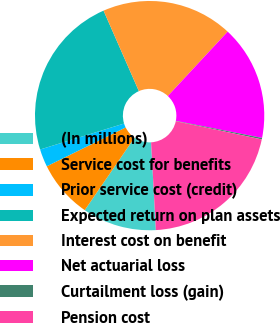Convert chart. <chart><loc_0><loc_0><loc_500><loc_500><pie_chart><fcel>(In millions)<fcel>Service cost for benefits<fcel>Prior service cost (credit)<fcel>Expected return on plan assets<fcel>Interest cost on benefit<fcel>Net actuarial loss<fcel>Curtailment loss (gain)<fcel>Pension cost<nl><fcel>10.44%<fcel>8.14%<fcel>2.51%<fcel>23.19%<fcel>18.5%<fcel>16.2%<fcel>0.21%<fcel>20.8%<nl></chart> 